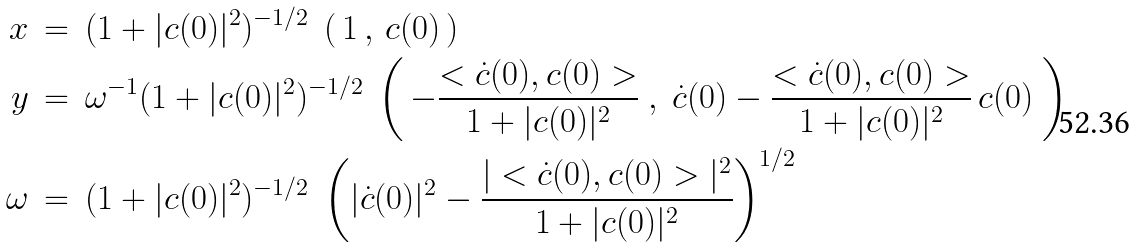Convert formula to latex. <formula><loc_0><loc_0><loc_500><loc_500>x \, & = \, ( 1 + | c ( 0 ) | ^ { 2 } ) ^ { - 1 / 2 } \ \left ( \, 1 \, , \, c ( 0 ) \, \right ) \\ y \, & = \, \omega ^ { - 1 } ( 1 + | c ( 0 ) | ^ { 2 } ) ^ { - 1 / 2 } \ \left ( \, - \frac { < \dot { c } ( 0 ) , c ( 0 ) > } { 1 + | c ( 0 ) | ^ { 2 } } \ , \ \dot { c } ( 0 ) - \frac { < \dot { c } ( 0 ) , c ( 0 ) > } { 1 + | c ( 0 ) | ^ { 2 } } \, c ( 0 ) \ \right ) \\ \omega \, & = \, ( 1 + | c ( 0 ) | ^ { 2 } ) ^ { - 1 / 2 } \ \left ( | \dot { c } ( 0 ) | ^ { 2 } - \frac { | < \dot { c } ( 0 ) , c ( 0 ) > | ^ { 2 } } { 1 + | c ( 0 ) | ^ { 2 } } \right ) ^ { 1 / 2 }</formula> 